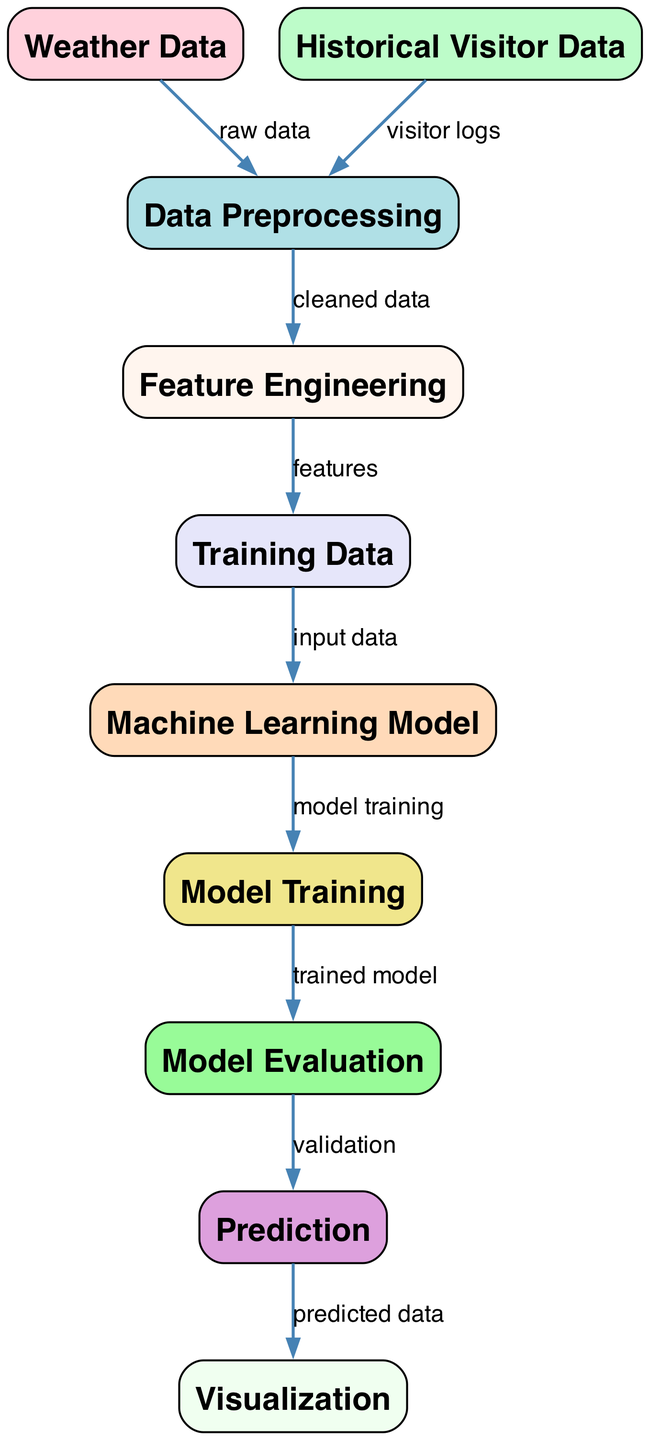What is the starting point of the diagram? The diagram starts with the "Weather Data" node, which is the first node listed and has no incoming edges. It serves as the initial data source.
Answer: Weather Data How many nodes are present in the diagram? The diagram contains 10 nodes, as counted from the list of nodes provided.
Answer: 10 Which node indicates the process of cleaning data? The "Data Preprocessing" node indicates the process of cleaning and transforming data, as described in its caption.
Answer: Data Preprocessing What type of model is used for predictions? The "Machine Learning Model" node suggests using algorithms like Linear Regression or Random Forest for predictions of daily visitors.
Answer: Machine Learning Model What is the relationship between "Model Evaluation" and "Prediction"? The "Model Evaluation" node leads to the "Prediction" node, meaning the evaluation phase should occur before making predictions based on the trained model.
Answer: Validation Which step generates new features from the weather data? The "Feature Engineering" node indicates the generation of new features such as "Temperature," "Humidity," and "Day of Week" from the cleaned data.
Answer: Feature Engineering What is the output of the diagram? The final output of the diagram shown is the "Visualization" node, where the predicted data is displayed in a graphical format.
Answer: Visualization How is the model trained according to the diagram? The "Model Training" node states that the model is trained using the "Training Data" as input to build the predictive model for daily visitors.
Answer: Model Training Which edge connects "Historical Visitor Data" to the diagram? The edge labeled "visitor logs" connects the "Historical Visitor Data" node to "Data Preprocessing," indicating its role in the data preparation process.
Answer: visitor logs What is the purpose of the "Visualization" node? The "Visualization" node is meant to display the results of the predictions using graphs and charts based on the predicted data from the previous step.
Answer: Displaying results 